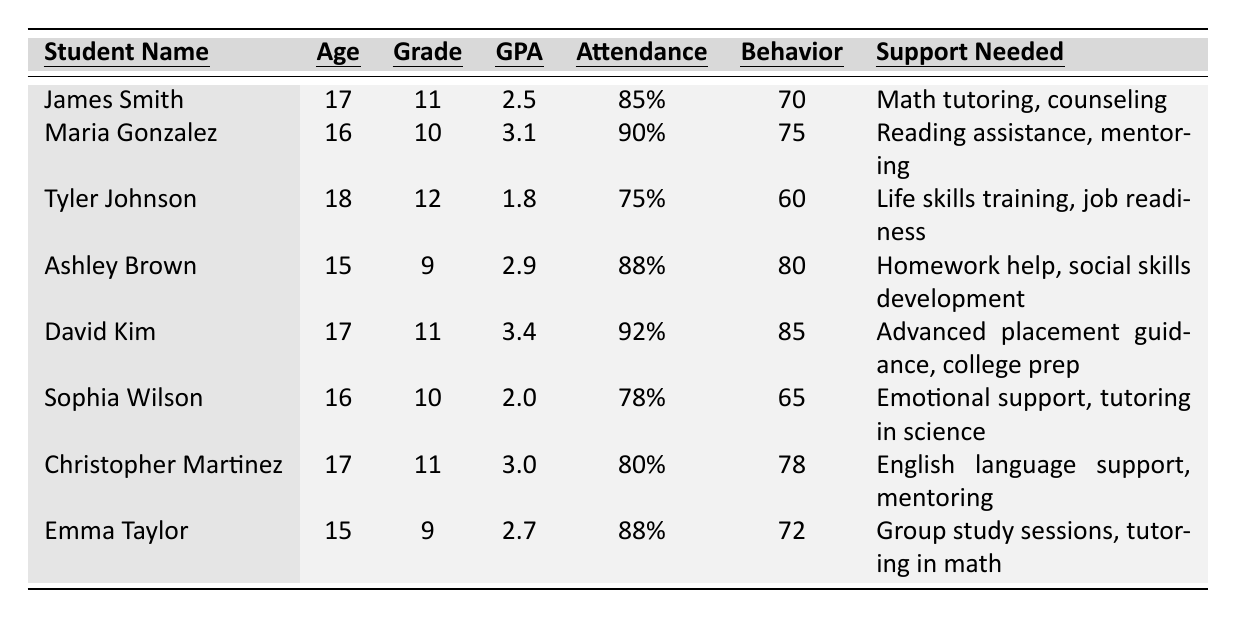What is the GPA of Tyler Johnson? Tyler Johnson's GPA is listed in the table next to his name. It shows a value of 1.8.
Answer: 1.8 What is the attendance rate of David Kim? The attendance rate for David Kim can be found in the same row as his name, which is 92%.
Answer: 92% Which student has the highest Behavioral Score? By comparing the Behavioral Scores in the table, David Kim has the highest score at 85.
Answer: David Kim How many students have a GPA below 3.0? To find this, count the students with a GPA less than 3.0 by checking the GPA values: James Smith (2.5), Tyler Johnson (1.8), Sophia Wilson (2.0), and Emma Taylor (2.7). This gives us a total of 4 students.
Answer: 4 Is there any student who needs support in math? By examining the Support Needed column, James Smith and Emma Taylor both require assistance in math (James: "Math tutoring, counseling" and Emma: "Tutoring in math"). Therefore, the answer is yes.
Answer: Yes What is the average GPA of the students listed? To calculate the average GPA, add all GPAs listed: (2.5 + 3.1 + 1.8 + 2.9 + 3.4 + 2.0 + 3.0 + 2.7) = 21.4. Then, divide by the number of students (8): 21.4 / 8 = 2.675.
Answer: 2.675 Which grade has the most students listed? Count the students in each grade: Grade 9 has 2 (Ashley and Emma), Grade 10 has 2 (Maria and Sophia), Grade 11 has 3 (James, David, Christopher), and Grade 12 has 1 (Tyler). The most students are in Grade 11.
Answer: Grade 11 Does Sophia Wilson have a higher Attendance Rate than Tyler Johnson? Compare the Attendance Rates: Sophia's is 78%, and Tyler's is 75%. Since 78% is greater than 75%, Sophia has a higher attendance rate.
Answer: Yes How many students are in Grade 10 or 12? Identify which students are in Grade 10 (Maria and Sophia) and Grade 12 (Tyler), then count them: 2 from Grade 10 and 1 from Grade 12 totals 3 students.
Answer: 3 